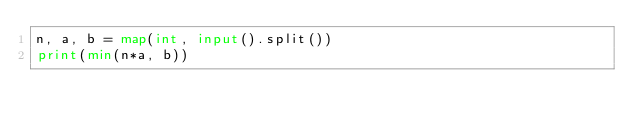Convert code to text. <code><loc_0><loc_0><loc_500><loc_500><_Python_>n, a, b = map(int, input().split())
print(min(n*a, b))
</code> 